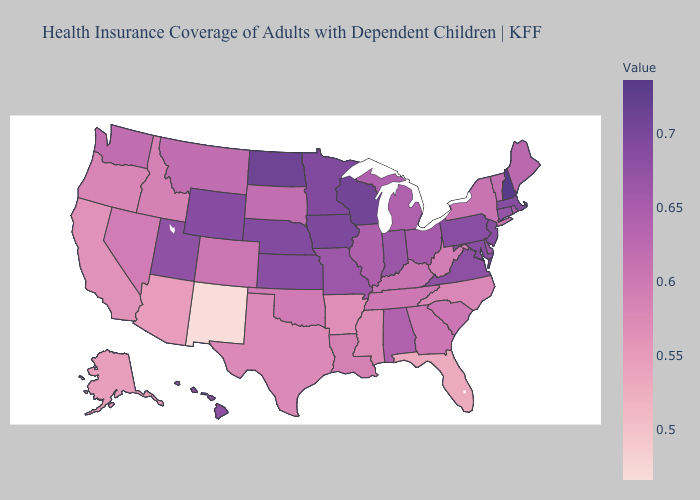Does New Jersey have the lowest value in the Northeast?
Short answer required. No. Which states have the lowest value in the USA?
Answer briefly. New Mexico. Does New Hampshire have the highest value in the Northeast?
Keep it brief. Yes. Is the legend a continuous bar?
Keep it brief. Yes. Is the legend a continuous bar?
Answer briefly. Yes. 